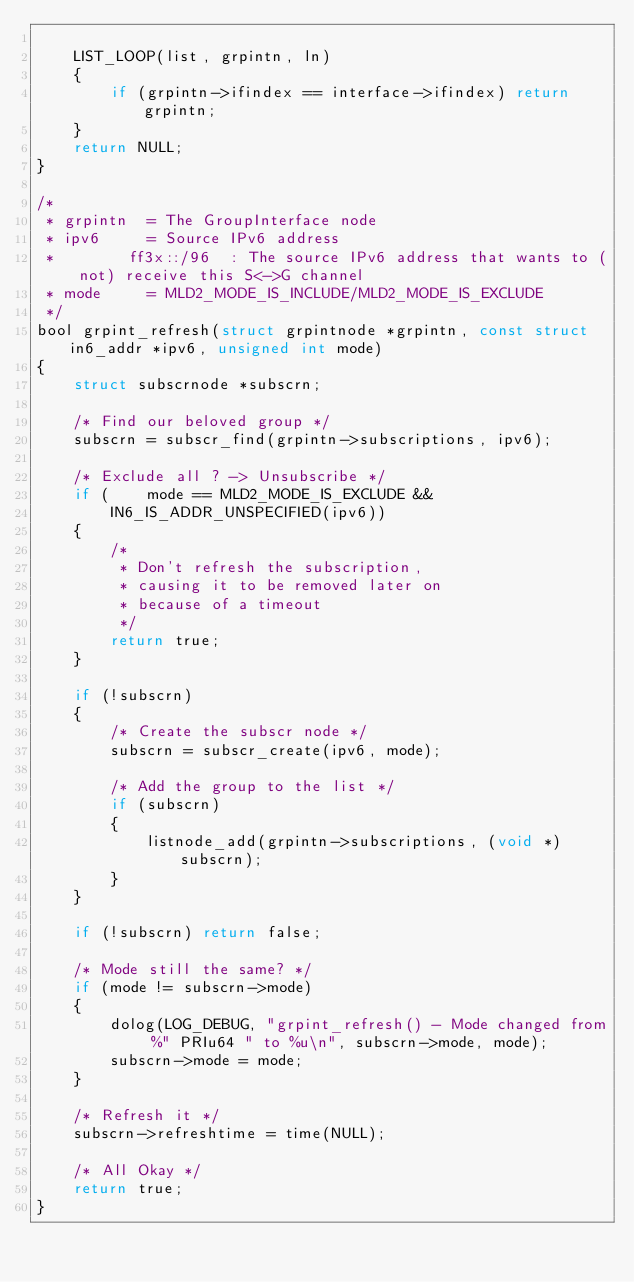<code> <loc_0><loc_0><loc_500><loc_500><_C_>
	LIST_LOOP(list, grpintn, ln)
	{
		if (grpintn->ifindex == interface->ifindex) return grpintn;
	}
	return NULL;
}

/*
 * grpintn	= The GroupInterface node
 * ipv6		= Source IPv6 address
 *		  ff3x::/96  : The source IPv6 address that wants to (not) receive this S<->G channel
 * mode		= MLD2_MODE_IS_INCLUDE/MLD2_MODE_IS_EXCLUDE
 */
bool grpint_refresh(struct grpintnode *grpintn, const struct in6_addr *ipv6, unsigned int mode)
{
	struct subscrnode *subscrn;

	/* Find our beloved group */
	subscrn = subscr_find(grpintn->subscriptions, ipv6);

	/* Exclude all ? -> Unsubscribe */
	if (	mode == MLD2_MODE_IS_EXCLUDE &&
		IN6_IS_ADDR_UNSPECIFIED(ipv6))
	{
		/*
		 * Don't refresh the subscription,
		 * causing it to be removed later on
		 * because of a timeout
		 */
		return true;
	}

	if (!subscrn)
	{
		/* Create the subscr node */
		subscrn = subscr_create(ipv6, mode);

		/* Add the group to the list */
		if (subscrn)
		{
			listnode_add(grpintn->subscriptions, (void *)subscrn);
		}
	}

	if (!subscrn) return false;

	/* Mode still the same? */
	if (mode != subscrn->mode)
	{
		dolog(LOG_DEBUG, "grpint_refresh() - Mode changed from %" PRIu64 " to %u\n", subscrn->mode, mode);
		subscrn->mode = mode;
	}

	/* Refresh it */
	subscrn->refreshtime = time(NULL);

	/* All Okay */
	return true;
}

</code> 